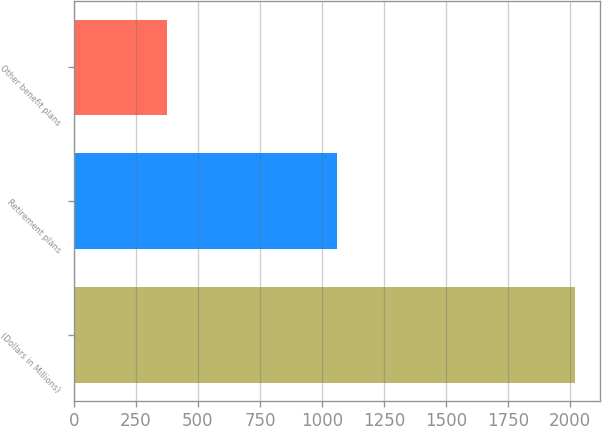Convert chart. <chart><loc_0><loc_0><loc_500><loc_500><bar_chart><fcel>(Dollars in Millions)<fcel>Retirement plans<fcel>Other benefit plans<nl><fcel>2019<fcel>1062<fcel>375<nl></chart> 